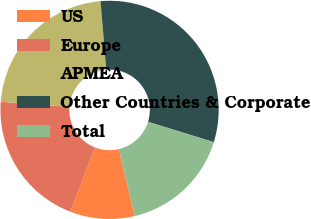Convert chart to OTSL. <chart><loc_0><loc_0><loc_500><loc_500><pie_chart><fcel>US<fcel>Europe<fcel>APMEA<fcel>Other Countries & Corporate<fcel>Total<nl><fcel>9.57%<fcel>20.33%<fcel>22.49%<fcel>31.1%<fcel>16.51%<nl></chart> 